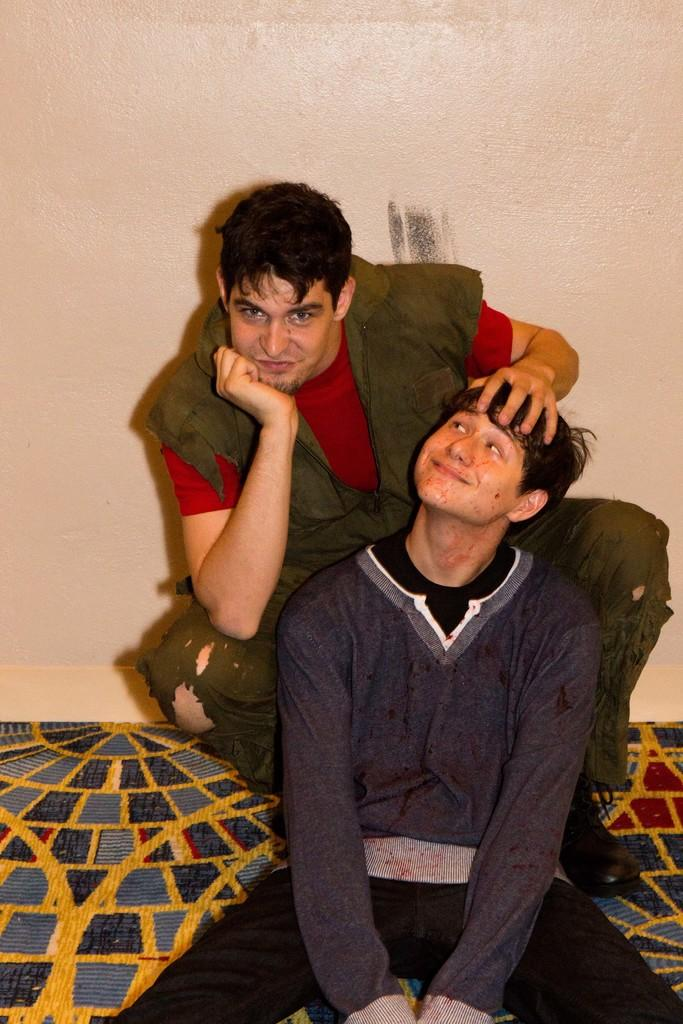How many people are in the foreground of the picture? There are two men in the foreground of the picture. What are the men doing in the image? The men are sitting on a mat-like object. What can be seen in the background of the picture? There is a well in the background of the picture. What type of cakes are the men baking in the picture? There is no indication of any cakes or baking activity in the image. 